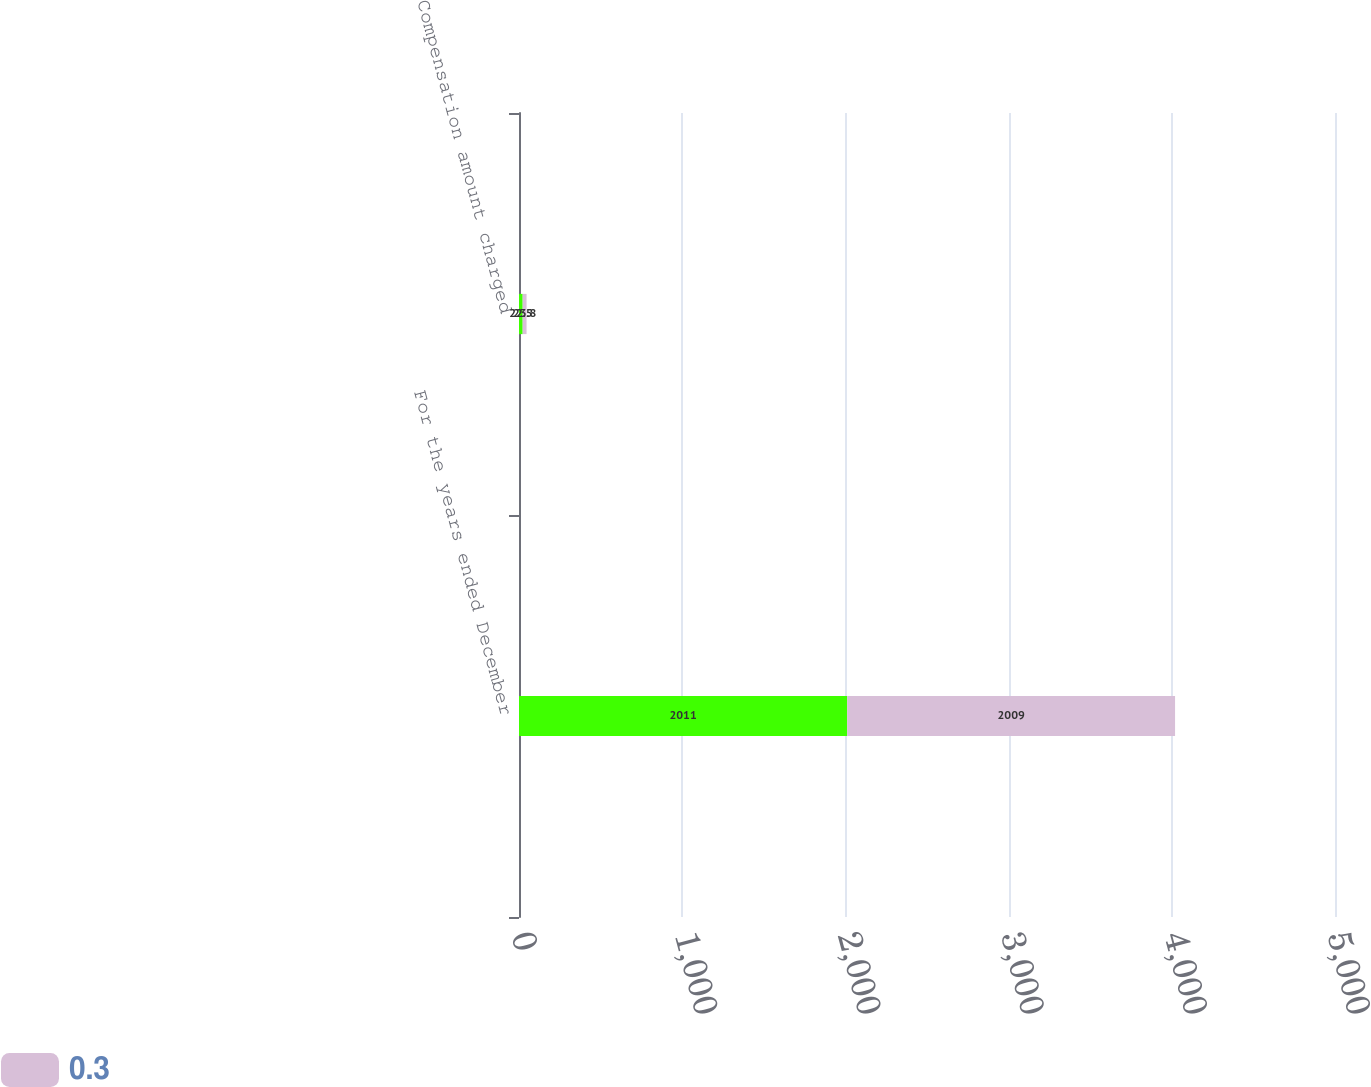<chart> <loc_0><loc_0><loc_500><loc_500><stacked_bar_chart><ecel><fcel>For the years ended December<fcel>Compensation amount charged<nl><fcel>nan<fcel>2011<fcel>22.5<nl><fcel>0.3<fcel>2009<fcel>23.8<nl></chart> 